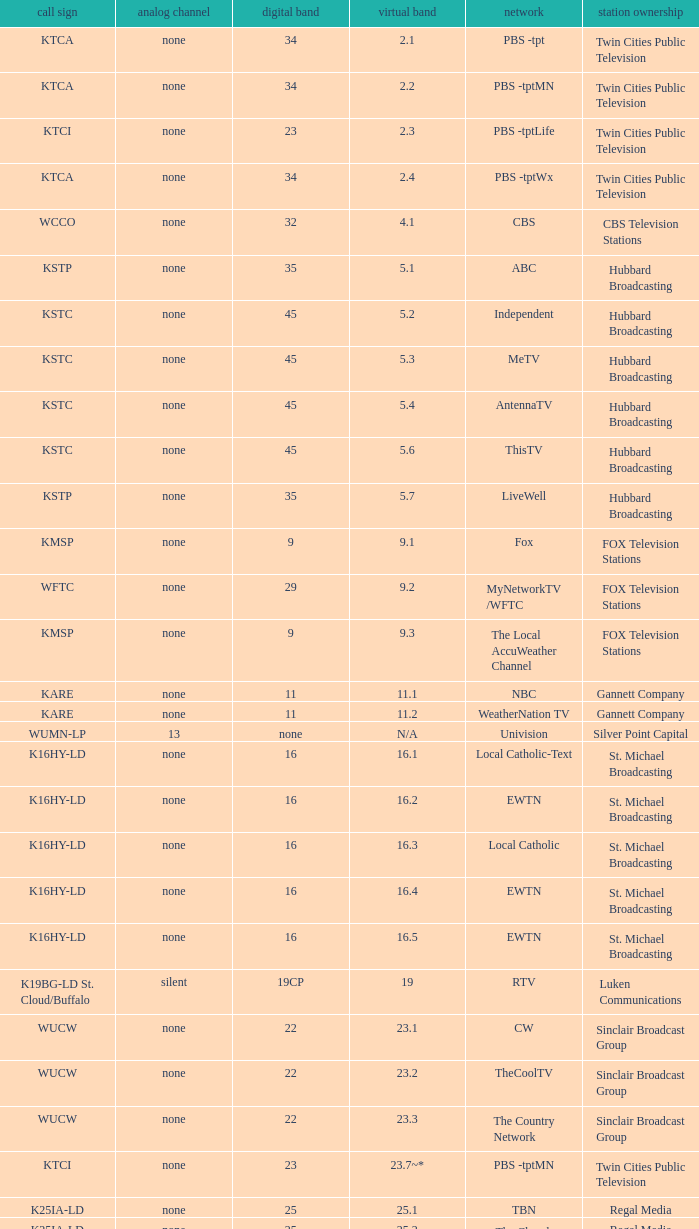Station Ownership of eicb tv, and a Call sign of ktcj-ld is what virtual network? 50.1. 